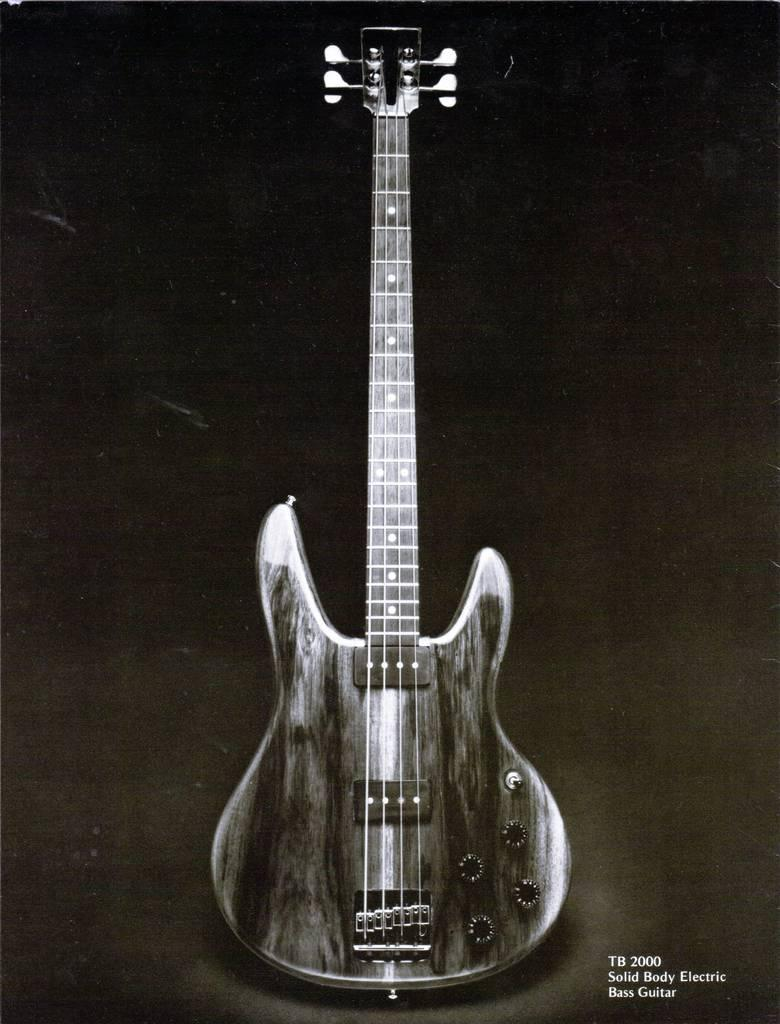What musical instrument is present in the image? There is a guitar in the image. How many strings does the guitar have? The guitar has four strings. Where is the guitar placed in the image? The guitar is placed on a surface. What color is the background of the image? The background of the image is black. What caption is written below the guitar in the image? There is no caption present in the image. 